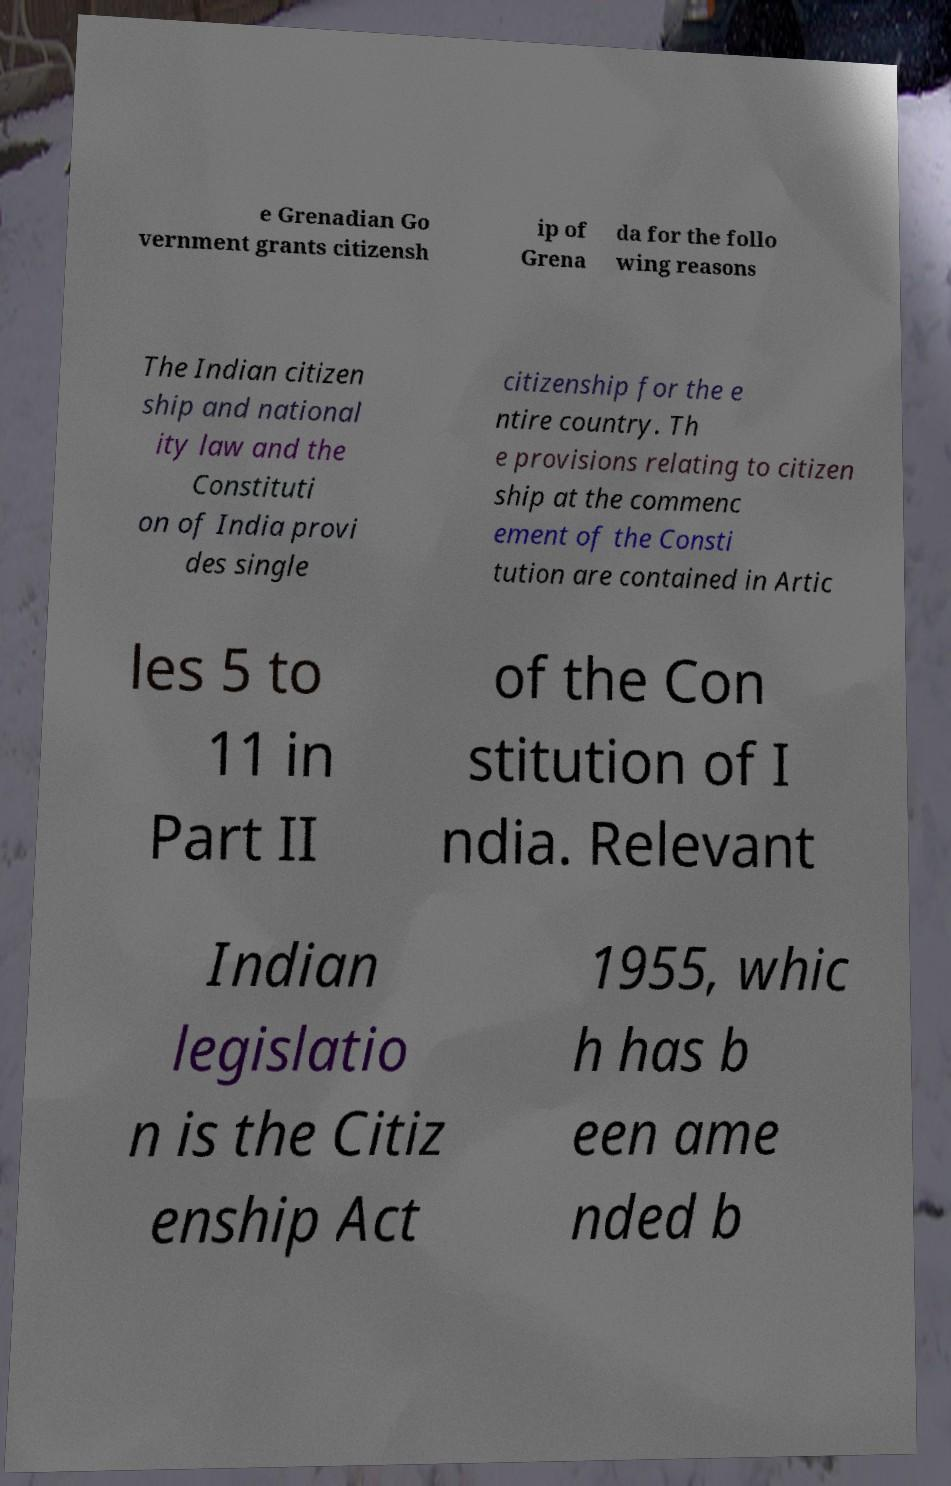Could you assist in decoding the text presented in this image and type it out clearly? e Grenadian Go vernment grants citizensh ip of Grena da for the follo wing reasons The Indian citizen ship and national ity law and the Constituti on of India provi des single citizenship for the e ntire country. Th e provisions relating to citizen ship at the commenc ement of the Consti tution are contained in Artic les 5 to 11 in Part II of the Con stitution of I ndia. Relevant Indian legislatio n is the Citiz enship Act 1955, whic h has b een ame nded b 